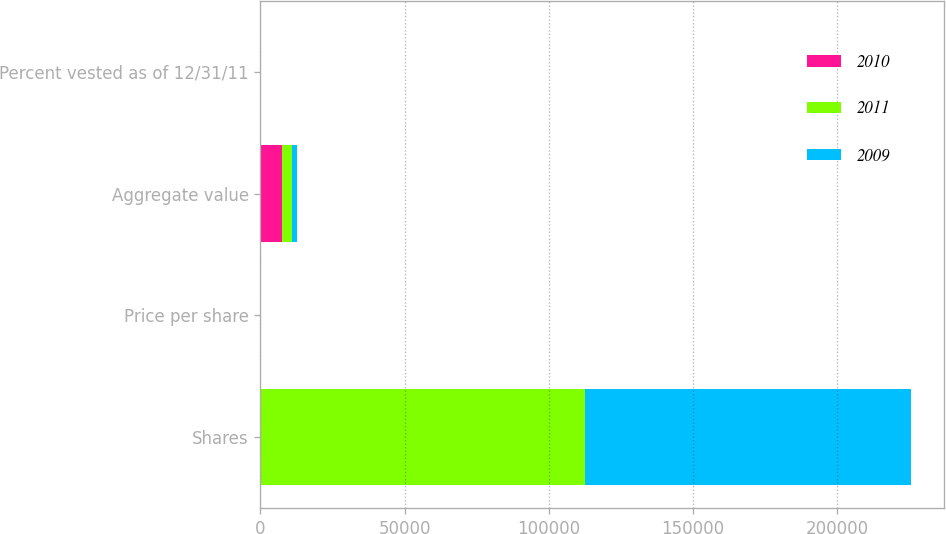Convert chart. <chart><loc_0><loc_0><loc_500><loc_500><stacked_bar_chart><ecel><fcel>Shares<fcel>Price per share<fcel>Aggregate value<fcel>Percent vested as of 12/31/11<nl><fcel>2010<fcel>44.39<fcel>44.39<fcel>7424<fcel>0<nl><fcel>2011<fcel>112500<fcel>30.87<fcel>3473<fcel>20<nl><fcel>2009<fcel>113250<fcel>15.67<fcel>1774<fcel>40<nl></chart> 